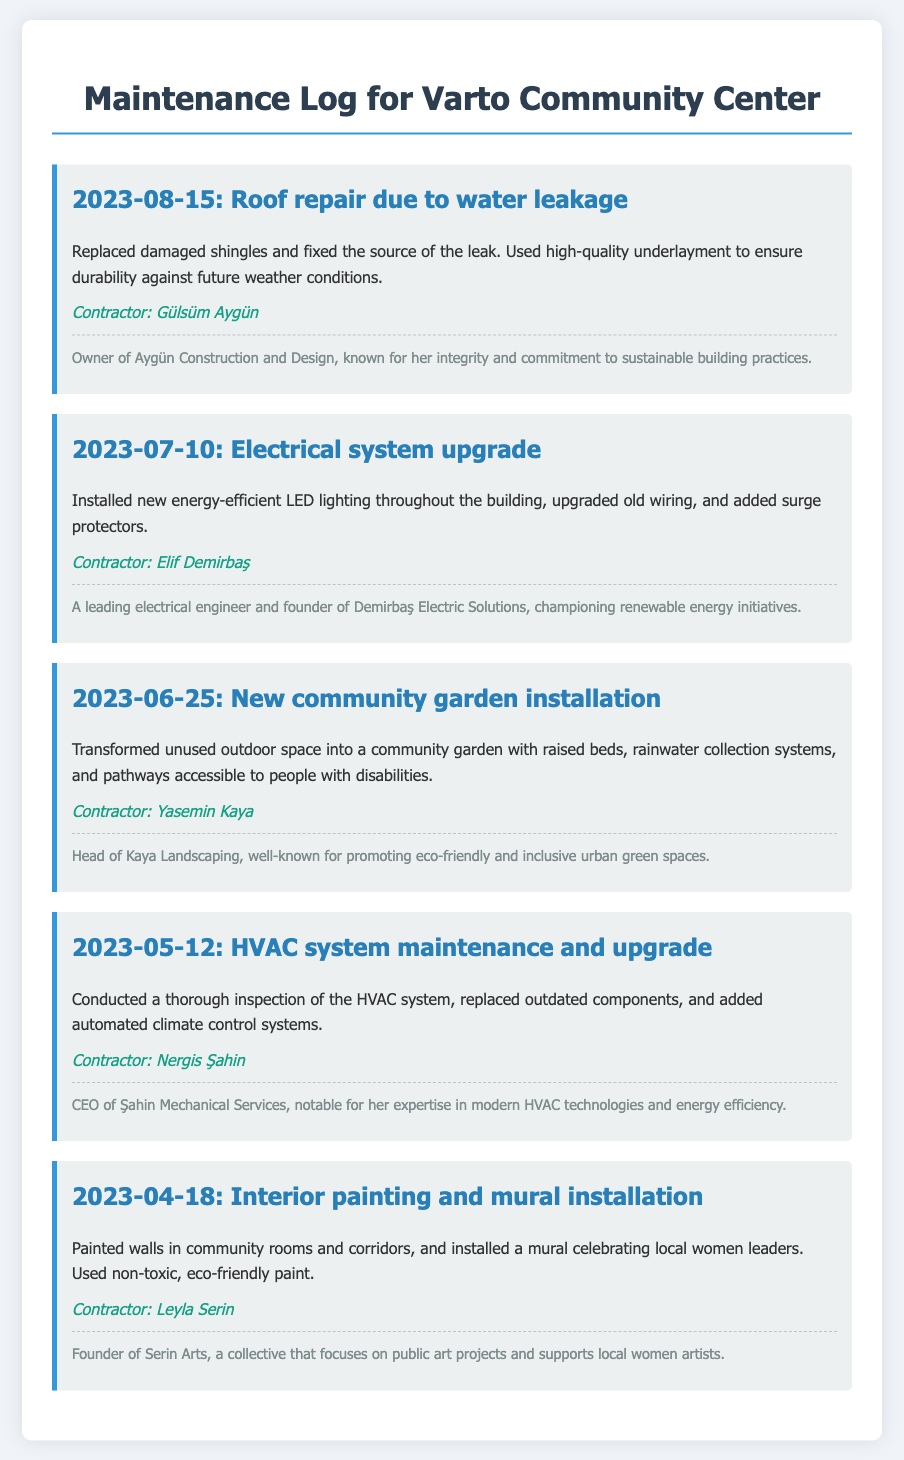What was the date of the roof repair? The roof repair was conducted on August 15, 2023.
Answer: August 15, 2023 Who was the contractor for the electrical system upgrade? The contractor for the electrical system upgrade was Elif Demirbaş.
Answer: Elif Demirbaş What type of system was upgraded on May 12, 2023? The document mentions an HVAC system upgrade conducted on that date.
Answer: HVAC system Which contractor installed a mural celebrating local women leaders? Leyla Serin was responsible for the mural installation in the community center.
Answer: Leyla Serin What sustainable practice did Gülsüm Aygün focus on in her construction work? Gülsüm Aygün is known for her commitment to sustainable building practices.
Answer: Sustainable building practices How many maintenance tasks were listed in the log? The log contains five entries detailing various maintenance tasks.
Answer: Five Which contractor is noted for promoting eco-friendly garden designs? Yasemin Kaya is recognized for promoting eco-friendly and inclusive urban green spaces.
Answer: Yasemin Kaya What significant feature was included in the community garden installation? The community garden installation included rainwater collection systems.
Answer: Rainwater collection systems What type of paint was used for the interior painting? Non-toxic, eco-friendly paint was used for the interior painting project.
Answer: Non-toxic, eco-friendly paint 